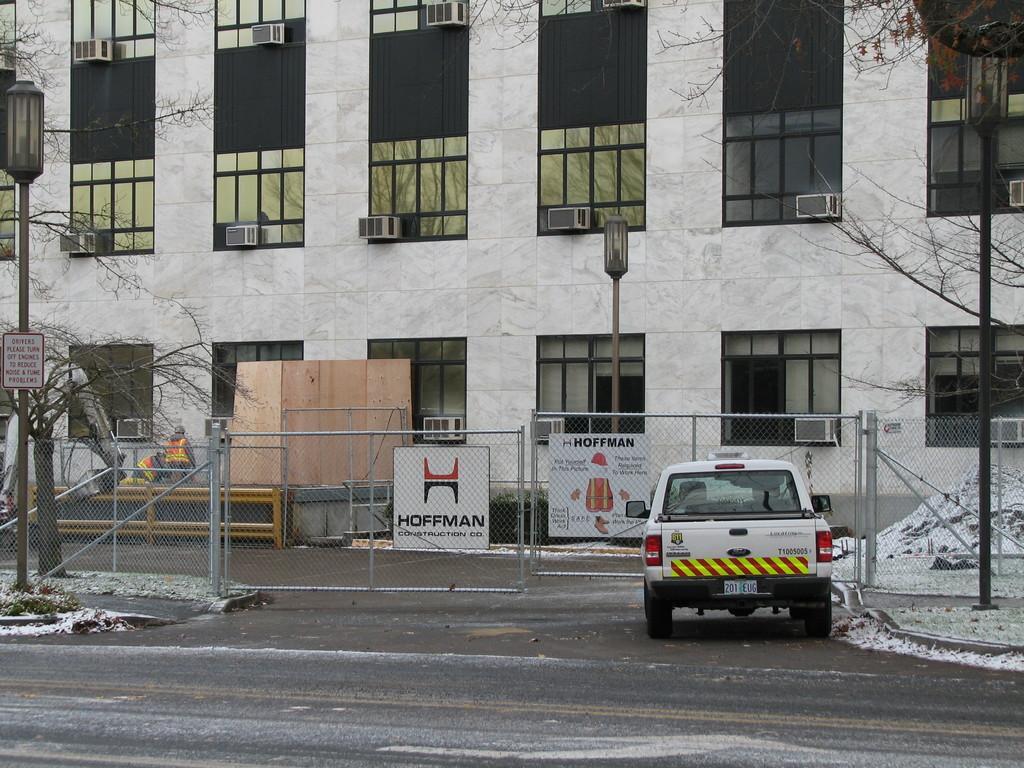How would you summarize this image in a sentence or two? In this image there is vehicle on a road, in the background there is fencing, on either side of the fencing there is are poles, behind the fencing there is a building for that building there are windows. 